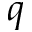<formula> <loc_0><loc_0><loc_500><loc_500>q</formula> 